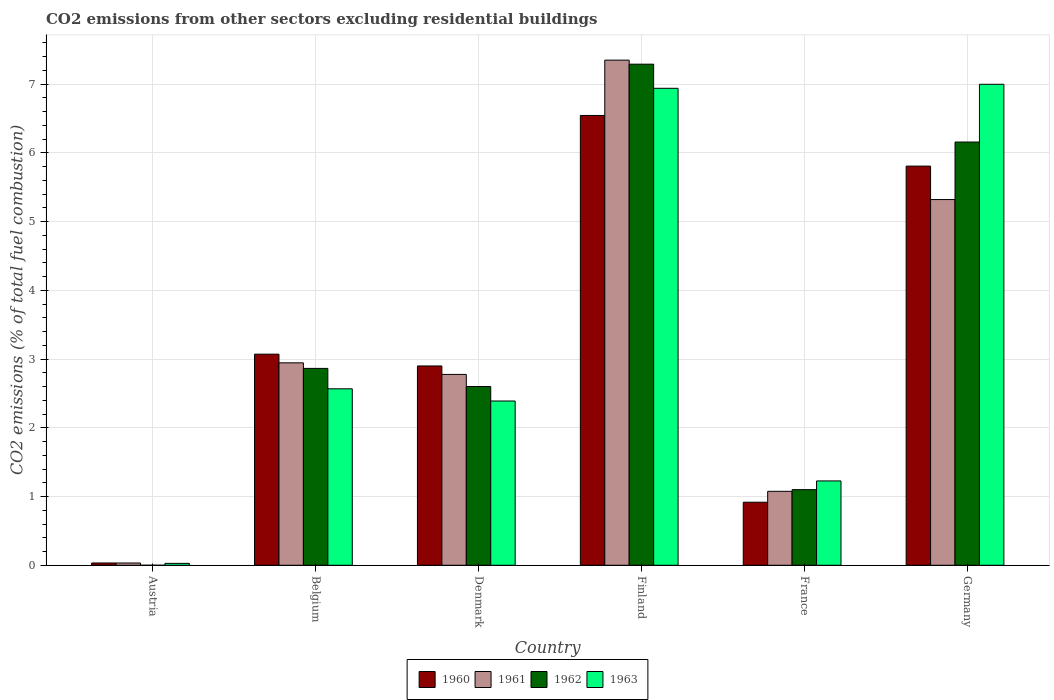How many different coloured bars are there?
Provide a succinct answer. 4. How many groups of bars are there?
Give a very brief answer. 6. Are the number of bars per tick equal to the number of legend labels?
Keep it short and to the point. No. In how many cases, is the number of bars for a given country not equal to the number of legend labels?
Your answer should be compact. 1. What is the total CO2 emitted in 1962 in France?
Make the answer very short. 1.1. Across all countries, what is the maximum total CO2 emitted in 1963?
Offer a very short reply. 7. Across all countries, what is the minimum total CO2 emitted in 1960?
Offer a terse response. 0.03. What is the total total CO2 emitted in 1962 in the graph?
Provide a succinct answer. 20.01. What is the difference between the total CO2 emitted in 1961 in Austria and that in Denmark?
Provide a short and direct response. -2.74. What is the difference between the total CO2 emitted in 1963 in Belgium and the total CO2 emitted in 1960 in Finland?
Your answer should be very brief. -3.98. What is the average total CO2 emitted in 1961 per country?
Your answer should be compact. 3.25. What is the difference between the total CO2 emitted of/in 1962 and total CO2 emitted of/in 1961 in Finland?
Make the answer very short. -0.06. In how many countries, is the total CO2 emitted in 1961 greater than 3.6?
Keep it short and to the point. 2. What is the ratio of the total CO2 emitted in 1961 in Denmark to that in France?
Your answer should be very brief. 2.58. Is the total CO2 emitted in 1961 in Denmark less than that in Germany?
Provide a succinct answer. Yes. Is the difference between the total CO2 emitted in 1962 in Denmark and Germany greater than the difference between the total CO2 emitted in 1961 in Denmark and Germany?
Make the answer very short. No. What is the difference between the highest and the second highest total CO2 emitted in 1960?
Offer a very short reply. -2.74. What is the difference between the highest and the lowest total CO2 emitted in 1962?
Provide a succinct answer. 7.29. In how many countries, is the total CO2 emitted in 1962 greater than the average total CO2 emitted in 1962 taken over all countries?
Ensure brevity in your answer.  2. Is the sum of the total CO2 emitted in 1961 in Belgium and Germany greater than the maximum total CO2 emitted in 1963 across all countries?
Offer a terse response. Yes. Is it the case that in every country, the sum of the total CO2 emitted in 1963 and total CO2 emitted in 1961 is greater than the total CO2 emitted in 1962?
Ensure brevity in your answer.  Yes. Does the graph contain grids?
Your response must be concise. Yes. How are the legend labels stacked?
Your response must be concise. Horizontal. What is the title of the graph?
Provide a short and direct response. CO2 emissions from other sectors excluding residential buildings. Does "2000" appear as one of the legend labels in the graph?
Provide a short and direct response. No. What is the label or title of the Y-axis?
Offer a very short reply. CO2 emissions (% of total fuel combustion). What is the CO2 emissions (% of total fuel combustion) in 1960 in Austria?
Keep it short and to the point. 0.03. What is the CO2 emissions (% of total fuel combustion) of 1961 in Austria?
Offer a terse response. 0.03. What is the CO2 emissions (% of total fuel combustion) in 1962 in Austria?
Your response must be concise. 0. What is the CO2 emissions (% of total fuel combustion) of 1963 in Austria?
Your answer should be very brief. 0.03. What is the CO2 emissions (% of total fuel combustion) of 1960 in Belgium?
Your answer should be compact. 3.07. What is the CO2 emissions (% of total fuel combustion) of 1961 in Belgium?
Make the answer very short. 2.95. What is the CO2 emissions (% of total fuel combustion) of 1962 in Belgium?
Keep it short and to the point. 2.86. What is the CO2 emissions (% of total fuel combustion) of 1963 in Belgium?
Your answer should be compact. 2.57. What is the CO2 emissions (% of total fuel combustion) of 1960 in Denmark?
Make the answer very short. 2.9. What is the CO2 emissions (% of total fuel combustion) of 1961 in Denmark?
Keep it short and to the point. 2.78. What is the CO2 emissions (% of total fuel combustion) in 1962 in Denmark?
Give a very brief answer. 2.6. What is the CO2 emissions (% of total fuel combustion) of 1963 in Denmark?
Provide a short and direct response. 2.39. What is the CO2 emissions (% of total fuel combustion) of 1960 in Finland?
Keep it short and to the point. 6.54. What is the CO2 emissions (% of total fuel combustion) in 1961 in Finland?
Offer a very short reply. 7.35. What is the CO2 emissions (% of total fuel combustion) of 1962 in Finland?
Give a very brief answer. 7.29. What is the CO2 emissions (% of total fuel combustion) of 1963 in Finland?
Offer a terse response. 6.94. What is the CO2 emissions (% of total fuel combustion) of 1960 in France?
Offer a very short reply. 0.92. What is the CO2 emissions (% of total fuel combustion) of 1961 in France?
Your response must be concise. 1.08. What is the CO2 emissions (% of total fuel combustion) in 1962 in France?
Your answer should be very brief. 1.1. What is the CO2 emissions (% of total fuel combustion) of 1963 in France?
Your answer should be compact. 1.23. What is the CO2 emissions (% of total fuel combustion) of 1960 in Germany?
Give a very brief answer. 5.81. What is the CO2 emissions (% of total fuel combustion) in 1961 in Germany?
Offer a terse response. 5.32. What is the CO2 emissions (% of total fuel combustion) of 1962 in Germany?
Your answer should be compact. 6.16. What is the CO2 emissions (% of total fuel combustion) in 1963 in Germany?
Your answer should be very brief. 7. Across all countries, what is the maximum CO2 emissions (% of total fuel combustion) in 1960?
Your answer should be very brief. 6.54. Across all countries, what is the maximum CO2 emissions (% of total fuel combustion) of 1961?
Provide a short and direct response. 7.35. Across all countries, what is the maximum CO2 emissions (% of total fuel combustion) in 1962?
Keep it short and to the point. 7.29. Across all countries, what is the maximum CO2 emissions (% of total fuel combustion) in 1963?
Provide a short and direct response. 7. Across all countries, what is the minimum CO2 emissions (% of total fuel combustion) of 1960?
Offer a terse response. 0.03. Across all countries, what is the minimum CO2 emissions (% of total fuel combustion) in 1961?
Ensure brevity in your answer.  0.03. Across all countries, what is the minimum CO2 emissions (% of total fuel combustion) in 1963?
Provide a short and direct response. 0.03. What is the total CO2 emissions (% of total fuel combustion) in 1960 in the graph?
Offer a terse response. 19.27. What is the total CO2 emissions (% of total fuel combustion) in 1961 in the graph?
Ensure brevity in your answer.  19.5. What is the total CO2 emissions (% of total fuel combustion) of 1962 in the graph?
Give a very brief answer. 20.01. What is the total CO2 emissions (% of total fuel combustion) of 1963 in the graph?
Offer a terse response. 20.15. What is the difference between the CO2 emissions (% of total fuel combustion) in 1960 in Austria and that in Belgium?
Your answer should be very brief. -3.04. What is the difference between the CO2 emissions (% of total fuel combustion) in 1961 in Austria and that in Belgium?
Your answer should be very brief. -2.91. What is the difference between the CO2 emissions (% of total fuel combustion) of 1963 in Austria and that in Belgium?
Provide a short and direct response. -2.54. What is the difference between the CO2 emissions (% of total fuel combustion) in 1960 in Austria and that in Denmark?
Provide a short and direct response. -2.87. What is the difference between the CO2 emissions (% of total fuel combustion) of 1961 in Austria and that in Denmark?
Provide a succinct answer. -2.74. What is the difference between the CO2 emissions (% of total fuel combustion) in 1963 in Austria and that in Denmark?
Your answer should be very brief. -2.36. What is the difference between the CO2 emissions (% of total fuel combustion) in 1960 in Austria and that in Finland?
Your response must be concise. -6.51. What is the difference between the CO2 emissions (% of total fuel combustion) of 1961 in Austria and that in Finland?
Your answer should be very brief. -7.32. What is the difference between the CO2 emissions (% of total fuel combustion) of 1963 in Austria and that in Finland?
Ensure brevity in your answer.  -6.91. What is the difference between the CO2 emissions (% of total fuel combustion) in 1960 in Austria and that in France?
Your response must be concise. -0.88. What is the difference between the CO2 emissions (% of total fuel combustion) of 1961 in Austria and that in France?
Offer a very short reply. -1.04. What is the difference between the CO2 emissions (% of total fuel combustion) in 1963 in Austria and that in France?
Give a very brief answer. -1.2. What is the difference between the CO2 emissions (% of total fuel combustion) of 1960 in Austria and that in Germany?
Make the answer very short. -5.77. What is the difference between the CO2 emissions (% of total fuel combustion) in 1961 in Austria and that in Germany?
Your answer should be very brief. -5.29. What is the difference between the CO2 emissions (% of total fuel combustion) of 1963 in Austria and that in Germany?
Keep it short and to the point. -6.97. What is the difference between the CO2 emissions (% of total fuel combustion) in 1960 in Belgium and that in Denmark?
Provide a short and direct response. 0.17. What is the difference between the CO2 emissions (% of total fuel combustion) of 1961 in Belgium and that in Denmark?
Your answer should be very brief. 0.17. What is the difference between the CO2 emissions (% of total fuel combustion) in 1962 in Belgium and that in Denmark?
Keep it short and to the point. 0.26. What is the difference between the CO2 emissions (% of total fuel combustion) of 1963 in Belgium and that in Denmark?
Your answer should be compact. 0.18. What is the difference between the CO2 emissions (% of total fuel combustion) in 1960 in Belgium and that in Finland?
Give a very brief answer. -3.47. What is the difference between the CO2 emissions (% of total fuel combustion) in 1961 in Belgium and that in Finland?
Make the answer very short. -4.4. What is the difference between the CO2 emissions (% of total fuel combustion) of 1962 in Belgium and that in Finland?
Provide a short and direct response. -4.43. What is the difference between the CO2 emissions (% of total fuel combustion) in 1963 in Belgium and that in Finland?
Offer a terse response. -4.37. What is the difference between the CO2 emissions (% of total fuel combustion) of 1960 in Belgium and that in France?
Offer a very short reply. 2.15. What is the difference between the CO2 emissions (% of total fuel combustion) in 1961 in Belgium and that in France?
Keep it short and to the point. 1.87. What is the difference between the CO2 emissions (% of total fuel combustion) in 1962 in Belgium and that in France?
Offer a very short reply. 1.76. What is the difference between the CO2 emissions (% of total fuel combustion) of 1963 in Belgium and that in France?
Make the answer very short. 1.34. What is the difference between the CO2 emissions (% of total fuel combustion) of 1960 in Belgium and that in Germany?
Provide a succinct answer. -2.74. What is the difference between the CO2 emissions (% of total fuel combustion) in 1961 in Belgium and that in Germany?
Offer a terse response. -2.38. What is the difference between the CO2 emissions (% of total fuel combustion) of 1962 in Belgium and that in Germany?
Your response must be concise. -3.29. What is the difference between the CO2 emissions (% of total fuel combustion) in 1963 in Belgium and that in Germany?
Give a very brief answer. -4.43. What is the difference between the CO2 emissions (% of total fuel combustion) of 1960 in Denmark and that in Finland?
Your response must be concise. -3.64. What is the difference between the CO2 emissions (% of total fuel combustion) in 1961 in Denmark and that in Finland?
Your answer should be very brief. -4.57. What is the difference between the CO2 emissions (% of total fuel combustion) in 1962 in Denmark and that in Finland?
Your response must be concise. -4.69. What is the difference between the CO2 emissions (% of total fuel combustion) in 1963 in Denmark and that in Finland?
Your response must be concise. -4.55. What is the difference between the CO2 emissions (% of total fuel combustion) in 1960 in Denmark and that in France?
Keep it short and to the point. 1.98. What is the difference between the CO2 emissions (% of total fuel combustion) in 1961 in Denmark and that in France?
Offer a very short reply. 1.7. What is the difference between the CO2 emissions (% of total fuel combustion) of 1962 in Denmark and that in France?
Your answer should be compact. 1.5. What is the difference between the CO2 emissions (% of total fuel combustion) of 1963 in Denmark and that in France?
Your answer should be very brief. 1.16. What is the difference between the CO2 emissions (% of total fuel combustion) of 1960 in Denmark and that in Germany?
Offer a terse response. -2.91. What is the difference between the CO2 emissions (% of total fuel combustion) in 1961 in Denmark and that in Germany?
Ensure brevity in your answer.  -2.54. What is the difference between the CO2 emissions (% of total fuel combustion) in 1962 in Denmark and that in Germany?
Make the answer very short. -3.56. What is the difference between the CO2 emissions (% of total fuel combustion) in 1963 in Denmark and that in Germany?
Give a very brief answer. -4.61. What is the difference between the CO2 emissions (% of total fuel combustion) of 1960 in Finland and that in France?
Provide a succinct answer. 5.63. What is the difference between the CO2 emissions (% of total fuel combustion) of 1961 in Finland and that in France?
Keep it short and to the point. 6.27. What is the difference between the CO2 emissions (% of total fuel combustion) in 1962 in Finland and that in France?
Make the answer very short. 6.19. What is the difference between the CO2 emissions (% of total fuel combustion) of 1963 in Finland and that in France?
Your answer should be very brief. 5.71. What is the difference between the CO2 emissions (% of total fuel combustion) in 1960 in Finland and that in Germany?
Give a very brief answer. 0.74. What is the difference between the CO2 emissions (% of total fuel combustion) in 1961 in Finland and that in Germany?
Provide a short and direct response. 2.03. What is the difference between the CO2 emissions (% of total fuel combustion) in 1962 in Finland and that in Germany?
Your response must be concise. 1.13. What is the difference between the CO2 emissions (% of total fuel combustion) in 1963 in Finland and that in Germany?
Make the answer very short. -0.06. What is the difference between the CO2 emissions (% of total fuel combustion) in 1960 in France and that in Germany?
Your answer should be compact. -4.89. What is the difference between the CO2 emissions (% of total fuel combustion) in 1961 in France and that in Germany?
Provide a short and direct response. -4.25. What is the difference between the CO2 emissions (% of total fuel combustion) in 1962 in France and that in Germany?
Make the answer very short. -5.06. What is the difference between the CO2 emissions (% of total fuel combustion) of 1963 in France and that in Germany?
Your response must be concise. -5.77. What is the difference between the CO2 emissions (% of total fuel combustion) of 1960 in Austria and the CO2 emissions (% of total fuel combustion) of 1961 in Belgium?
Make the answer very short. -2.91. What is the difference between the CO2 emissions (% of total fuel combustion) in 1960 in Austria and the CO2 emissions (% of total fuel combustion) in 1962 in Belgium?
Keep it short and to the point. -2.83. What is the difference between the CO2 emissions (% of total fuel combustion) of 1960 in Austria and the CO2 emissions (% of total fuel combustion) of 1963 in Belgium?
Provide a succinct answer. -2.53. What is the difference between the CO2 emissions (% of total fuel combustion) in 1961 in Austria and the CO2 emissions (% of total fuel combustion) in 1962 in Belgium?
Offer a very short reply. -2.83. What is the difference between the CO2 emissions (% of total fuel combustion) in 1961 in Austria and the CO2 emissions (% of total fuel combustion) in 1963 in Belgium?
Provide a short and direct response. -2.53. What is the difference between the CO2 emissions (% of total fuel combustion) of 1960 in Austria and the CO2 emissions (% of total fuel combustion) of 1961 in Denmark?
Offer a terse response. -2.74. What is the difference between the CO2 emissions (% of total fuel combustion) of 1960 in Austria and the CO2 emissions (% of total fuel combustion) of 1962 in Denmark?
Make the answer very short. -2.57. What is the difference between the CO2 emissions (% of total fuel combustion) of 1960 in Austria and the CO2 emissions (% of total fuel combustion) of 1963 in Denmark?
Provide a short and direct response. -2.36. What is the difference between the CO2 emissions (% of total fuel combustion) in 1961 in Austria and the CO2 emissions (% of total fuel combustion) in 1962 in Denmark?
Ensure brevity in your answer.  -2.57. What is the difference between the CO2 emissions (% of total fuel combustion) of 1961 in Austria and the CO2 emissions (% of total fuel combustion) of 1963 in Denmark?
Keep it short and to the point. -2.36. What is the difference between the CO2 emissions (% of total fuel combustion) of 1960 in Austria and the CO2 emissions (% of total fuel combustion) of 1961 in Finland?
Keep it short and to the point. -7.32. What is the difference between the CO2 emissions (% of total fuel combustion) in 1960 in Austria and the CO2 emissions (% of total fuel combustion) in 1962 in Finland?
Provide a succinct answer. -7.26. What is the difference between the CO2 emissions (% of total fuel combustion) in 1960 in Austria and the CO2 emissions (% of total fuel combustion) in 1963 in Finland?
Offer a very short reply. -6.91. What is the difference between the CO2 emissions (% of total fuel combustion) of 1961 in Austria and the CO2 emissions (% of total fuel combustion) of 1962 in Finland?
Provide a succinct answer. -7.26. What is the difference between the CO2 emissions (% of total fuel combustion) of 1961 in Austria and the CO2 emissions (% of total fuel combustion) of 1963 in Finland?
Keep it short and to the point. -6.91. What is the difference between the CO2 emissions (% of total fuel combustion) in 1960 in Austria and the CO2 emissions (% of total fuel combustion) in 1961 in France?
Your answer should be compact. -1.04. What is the difference between the CO2 emissions (% of total fuel combustion) of 1960 in Austria and the CO2 emissions (% of total fuel combustion) of 1962 in France?
Offer a very short reply. -1.07. What is the difference between the CO2 emissions (% of total fuel combustion) in 1960 in Austria and the CO2 emissions (% of total fuel combustion) in 1963 in France?
Keep it short and to the point. -1.19. What is the difference between the CO2 emissions (% of total fuel combustion) in 1961 in Austria and the CO2 emissions (% of total fuel combustion) in 1962 in France?
Offer a very short reply. -1.07. What is the difference between the CO2 emissions (% of total fuel combustion) of 1961 in Austria and the CO2 emissions (% of total fuel combustion) of 1963 in France?
Your answer should be compact. -1.19. What is the difference between the CO2 emissions (% of total fuel combustion) in 1960 in Austria and the CO2 emissions (% of total fuel combustion) in 1961 in Germany?
Make the answer very short. -5.29. What is the difference between the CO2 emissions (% of total fuel combustion) in 1960 in Austria and the CO2 emissions (% of total fuel combustion) in 1962 in Germany?
Provide a short and direct response. -6.12. What is the difference between the CO2 emissions (% of total fuel combustion) of 1960 in Austria and the CO2 emissions (% of total fuel combustion) of 1963 in Germany?
Give a very brief answer. -6.97. What is the difference between the CO2 emissions (% of total fuel combustion) in 1961 in Austria and the CO2 emissions (% of total fuel combustion) in 1962 in Germany?
Your answer should be compact. -6.12. What is the difference between the CO2 emissions (% of total fuel combustion) of 1961 in Austria and the CO2 emissions (% of total fuel combustion) of 1963 in Germany?
Your response must be concise. -6.97. What is the difference between the CO2 emissions (% of total fuel combustion) in 1960 in Belgium and the CO2 emissions (% of total fuel combustion) in 1961 in Denmark?
Your response must be concise. 0.29. What is the difference between the CO2 emissions (% of total fuel combustion) in 1960 in Belgium and the CO2 emissions (% of total fuel combustion) in 1962 in Denmark?
Your answer should be very brief. 0.47. What is the difference between the CO2 emissions (% of total fuel combustion) of 1960 in Belgium and the CO2 emissions (% of total fuel combustion) of 1963 in Denmark?
Keep it short and to the point. 0.68. What is the difference between the CO2 emissions (% of total fuel combustion) of 1961 in Belgium and the CO2 emissions (% of total fuel combustion) of 1962 in Denmark?
Your answer should be compact. 0.34. What is the difference between the CO2 emissions (% of total fuel combustion) in 1961 in Belgium and the CO2 emissions (% of total fuel combustion) in 1963 in Denmark?
Offer a terse response. 0.56. What is the difference between the CO2 emissions (% of total fuel combustion) in 1962 in Belgium and the CO2 emissions (% of total fuel combustion) in 1963 in Denmark?
Give a very brief answer. 0.47. What is the difference between the CO2 emissions (% of total fuel combustion) in 1960 in Belgium and the CO2 emissions (% of total fuel combustion) in 1961 in Finland?
Offer a terse response. -4.28. What is the difference between the CO2 emissions (% of total fuel combustion) in 1960 in Belgium and the CO2 emissions (% of total fuel combustion) in 1962 in Finland?
Ensure brevity in your answer.  -4.22. What is the difference between the CO2 emissions (% of total fuel combustion) in 1960 in Belgium and the CO2 emissions (% of total fuel combustion) in 1963 in Finland?
Ensure brevity in your answer.  -3.87. What is the difference between the CO2 emissions (% of total fuel combustion) of 1961 in Belgium and the CO2 emissions (% of total fuel combustion) of 1962 in Finland?
Make the answer very short. -4.35. What is the difference between the CO2 emissions (% of total fuel combustion) in 1961 in Belgium and the CO2 emissions (% of total fuel combustion) in 1963 in Finland?
Your response must be concise. -3.99. What is the difference between the CO2 emissions (% of total fuel combustion) of 1962 in Belgium and the CO2 emissions (% of total fuel combustion) of 1963 in Finland?
Your answer should be very brief. -4.08. What is the difference between the CO2 emissions (% of total fuel combustion) of 1960 in Belgium and the CO2 emissions (% of total fuel combustion) of 1961 in France?
Keep it short and to the point. 2. What is the difference between the CO2 emissions (% of total fuel combustion) in 1960 in Belgium and the CO2 emissions (% of total fuel combustion) in 1962 in France?
Ensure brevity in your answer.  1.97. What is the difference between the CO2 emissions (% of total fuel combustion) of 1960 in Belgium and the CO2 emissions (% of total fuel combustion) of 1963 in France?
Your answer should be compact. 1.84. What is the difference between the CO2 emissions (% of total fuel combustion) of 1961 in Belgium and the CO2 emissions (% of total fuel combustion) of 1962 in France?
Make the answer very short. 1.84. What is the difference between the CO2 emissions (% of total fuel combustion) of 1961 in Belgium and the CO2 emissions (% of total fuel combustion) of 1963 in France?
Ensure brevity in your answer.  1.72. What is the difference between the CO2 emissions (% of total fuel combustion) in 1962 in Belgium and the CO2 emissions (% of total fuel combustion) in 1963 in France?
Your answer should be very brief. 1.64. What is the difference between the CO2 emissions (% of total fuel combustion) of 1960 in Belgium and the CO2 emissions (% of total fuel combustion) of 1961 in Germany?
Your answer should be compact. -2.25. What is the difference between the CO2 emissions (% of total fuel combustion) of 1960 in Belgium and the CO2 emissions (% of total fuel combustion) of 1962 in Germany?
Ensure brevity in your answer.  -3.09. What is the difference between the CO2 emissions (% of total fuel combustion) of 1960 in Belgium and the CO2 emissions (% of total fuel combustion) of 1963 in Germany?
Keep it short and to the point. -3.93. What is the difference between the CO2 emissions (% of total fuel combustion) of 1961 in Belgium and the CO2 emissions (% of total fuel combustion) of 1962 in Germany?
Offer a terse response. -3.21. What is the difference between the CO2 emissions (% of total fuel combustion) in 1961 in Belgium and the CO2 emissions (% of total fuel combustion) in 1963 in Germany?
Make the answer very short. -4.05. What is the difference between the CO2 emissions (% of total fuel combustion) of 1962 in Belgium and the CO2 emissions (% of total fuel combustion) of 1963 in Germany?
Make the answer very short. -4.13. What is the difference between the CO2 emissions (% of total fuel combustion) in 1960 in Denmark and the CO2 emissions (% of total fuel combustion) in 1961 in Finland?
Offer a terse response. -4.45. What is the difference between the CO2 emissions (% of total fuel combustion) of 1960 in Denmark and the CO2 emissions (% of total fuel combustion) of 1962 in Finland?
Provide a succinct answer. -4.39. What is the difference between the CO2 emissions (% of total fuel combustion) of 1960 in Denmark and the CO2 emissions (% of total fuel combustion) of 1963 in Finland?
Provide a succinct answer. -4.04. What is the difference between the CO2 emissions (% of total fuel combustion) of 1961 in Denmark and the CO2 emissions (% of total fuel combustion) of 1962 in Finland?
Your answer should be very brief. -4.51. What is the difference between the CO2 emissions (% of total fuel combustion) of 1961 in Denmark and the CO2 emissions (% of total fuel combustion) of 1963 in Finland?
Keep it short and to the point. -4.16. What is the difference between the CO2 emissions (% of total fuel combustion) of 1962 in Denmark and the CO2 emissions (% of total fuel combustion) of 1963 in Finland?
Give a very brief answer. -4.34. What is the difference between the CO2 emissions (% of total fuel combustion) of 1960 in Denmark and the CO2 emissions (% of total fuel combustion) of 1961 in France?
Ensure brevity in your answer.  1.82. What is the difference between the CO2 emissions (% of total fuel combustion) of 1960 in Denmark and the CO2 emissions (% of total fuel combustion) of 1962 in France?
Keep it short and to the point. 1.8. What is the difference between the CO2 emissions (% of total fuel combustion) in 1960 in Denmark and the CO2 emissions (% of total fuel combustion) in 1963 in France?
Provide a succinct answer. 1.67. What is the difference between the CO2 emissions (% of total fuel combustion) of 1961 in Denmark and the CO2 emissions (% of total fuel combustion) of 1962 in France?
Give a very brief answer. 1.68. What is the difference between the CO2 emissions (% of total fuel combustion) in 1961 in Denmark and the CO2 emissions (% of total fuel combustion) in 1963 in France?
Keep it short and to the point. 1.55. What is the difference between the CO2 emissions (% of total fuel combustion) in 1962 in Denmark and the CO2 emissions (% of total fuel combustion) in 1963 in France?
Your answer should be very brief. 1.37. What is the difference between the CO2 emissions (% of total fuel combustion) of 1960 in Denmark and the CO2 emissions (% of total fuel combustion) of 1961 in Germany?
Ensure brevity in your answer.  -2.42. What is the difference between the CO2 emissions (% of total fuel combustion) in 1960 in Denmark and the CO2 emissions (% of total fuel combustion) in 1962 in Germany?
Offer a terse response. -3.26. What is the difference between the CO2 emissions (% of total fuel combustion) of 1960 in Denmark and the CO2 emissions (% of total fuel combustion) of 1963 in Germany?
Your answer should be compact. -4.1. What is the difference between the CO2 emissions (% of total fuel combustion) in 1961 in Denmark and the CO2 emissions (% of total fuel combustion) in 1962 in Germany?
Offer a very short reply. -3.38. What is the difference between the CO2 emissions (% of total fuel combustion) of 1961 in Denmark and the CO2 emissions (% of total fuel combustion) of 1963 in Germany?
Your answer should be very brief. -4.22. What is the difference between the CO2 emissions (% of total fuel combustion) in 1962 in Denmark and the CO2 emissions (% of total fuel combustion) in 1963 in Germany?
Give a very brief answer. -4.4. What is the difference between the CO2 emissions (% of total fuel combustion) of 1960 in Finland and the CO2 emissions (% of total fuel combustion) of 1961 in France?
Your answer should be very brief. 5.47. What is the difference between the CO2 emissions (% of total fuel combustion) of 1960 in Finland and the CO2 emissions (% of total fuel combustion) of 1962 in France?
Your answer should be very brief. 5.44. What is the difference between the CO2 emissions (% of total fuel combustion) of 1960 in Finland and the CO2 emissions (% of total fuel combustion) of 1963 in France?
Give a very brief answer. 5.32. What is the difference between the CO2 emissions (% of total fuel combustion) in 1961 in Finland and the CO2 emissions (% of total fuel combustion) in 1962 in France?
Your answer should be very brief. 6.25. What is the difference between the CO2 emissions (% of total fuel combustion) in 1961 in Finland and the CO2 emissions (% of total fuel combustion) in 1963 in France?
Ensure brevity in your answer.  6.12. What is the difference between the CO2 emissions (% of total fuel combustion) of 1962 in Finland and the CO2 emissions (% of total fuel combustion) of 1963 in France?
Provide a succinct answer. 6.06. What is the difference between the CO2 emissions (% of total fuel combustion) in 1960 in Finland and the CO2 emissions (% of total fuel combustion) in 1961 in Germany?
Give a very brief answer. 1.22. What is the difference between the CO2 emissions (% of total fuel combustion) in 1960 in Finland and the CO2 emissions (% of total fuel combustion) in 1962 in Germany?
Ensure brevity in your answer.  0.39. What is the difference between the CO2 emissions (% of total fuel combustion) in 1960 in Finland and the CO2 emissions (% of total fuel combustion) in 1963 in Germany?
Give a very brief answer. -0.45. What is the difference between the CO2 emissions (% of total fuel combustion) of 1961 in Finland and the CO2 emissions (% of total fuel combustion) of 1962 in Germany?
Your answer should be very brief. 1.19. What is the difference between the CO2 emissions (% of total fuel combustion) of 1961 in Finland and the CO2 emissions (% of total fuel combustion) of 1963 in Germany?
Offer a terse response. 0.35. What is the difference between the CO2 emissions (% of total fuel combustion) in 1962 in Finland and the CO2 emissions (% of total fuel combustion) in 1963 in Germany?
Your answer should be very brief. 0.29. What is the difference between the CO2 emissions (% of total fuel combustion) in 1960 in France and the CO2 emissions (% of total fuel combustion) in 1961 in Germany?
Make the answer very short. -4.4. What is the difference between the CO2 emissions (% of total fuel combustion) of 1960 in France and the CO2 emissions (% of total fuel combustion) of 1962 in Germany?
Provide a short and direct response. -5.24. What is the difference between the CO2 emissions (% of total fuel combustion) of 1960 in France and the CO2 emissions (% of total fuel combustion) of 1963 in Germany?
Offer a terse response. -6.08. What is the difference between the CO2 emissions (% of total fuel combustion) of 1961 in France and the CO2 emissions (% of total fuel combustion) of 1962 in Germany?
Offer a very short reply. -5.08. What is the difference between the CO2 emissions (% of total fuel combustion) in 1961 in France and the CO2 emissions (% of total fuel combustion) in 1963 in Germany?
Provide a short and direct response. -5.92. What is the difference between the CO2 emissions (% of total fuel combustion) in 1962 in France and the CO2 emissions (% of total fuel combustion) in 1963 in Germany?
Your answer should be very brief. -5.9. What is the average CO2 emissions (% of total fuel combustion) in 1960 per country?
Keep it short and to the point. 3.21. What is the average CO2 emissions (% of total fuel combustion) of 1961 per country?
Give a very brief answer. 3.25. What is the average CO2 emissions (% of total fuel combustion) of 1962 per country?
Provide a succinct answer. 3.34. What is the average CO2 emissions (% of total fuel combustion) in 1963 per country?
Offer a very short reply. 3.36. What is the difference between the CO2 emissions (% of total fuel combustion) in 1960 and CO2 emissions (% of total fuel combustion) in 1963 in Austria?
Provide a short and direct response. 0.01. What is the difference between the CO2 emissions (% of total fuel combustion) in 1961 and CO2 emissions (% of total fuel combustion) in 1963 in Austria?
Make the answer very short. 0.01. What is the difference between the CO2 emissions (% of total fuel combustion) of 1960 and CO2 emissions (% of total fuel combustion) of 1961 in Belgium?
Offer a very short reply. 0.13. What is the difference between the CO2 emissions (% of total fuel combustion) in 1960 and CO2 emissions (% of total fuel combustion) in 1962 in Belgium?
Offer a very short reply. 0.21. What is the difference between the CO2 emissions (% of total fuel combustion) of 1960 and CO2 emissions (% of total fuel combustion) of 1963 in Belgium?
Keep it short and to the point. 0.5. What is the difference between the CO2 emissions (% of total fuel combustion) of 1961 and CO2 emissions (% of total fuel combustion) of 1962 in Belgium?
Offer a terse response. 0.08. What is the difference between the CO2 emissions (% of total fuel combustion) of 1961 and CO2 emissions (% of total fuel combustion) of 1963 in Belgium?
Give a very brief answer. 0.38. What is the difference between the CO2 emissions (% of total fuel combustion) in 1962 and CO2 emissions (% of total fuel combustion) in 1963 in Belgium?
Your response must be concise. 0.3. What is the difference between the CO2 emissions (% of total fuel combustion) in 1960 and CO2 emissions (% of total fuel combustion) in 1961 in Denmark?
Your response must be concise. 0.12. What is the difference between the CO2 emissions (% of total fuel combustion) of 1960 and CO2 emissions (% of total fuel combustion) of 1962 in Denmark?
Keep it short and to the point. 0.3. What is the difference between the CO2 emissions (% of total fuel combustion) in 1960 and CO2 emissions (% of total fuel combustion) in 1963 in Denmark?
Your response must be concise. 0.51. What is the difference between the CO2 emissions (% of total fuel combustion) in 1961 and CO2 emissions (% of total fuel combustion) in 1962 in Denmark?
Make the answer very short. 0.18. What is the difference between the CO2 emissions (% of total fuel combustion) in 1961 and CO2 emissions (% of total fuel combustion) in 1963 in Denmark?
Offer a very short reply. 0.39. What is the difference between the CO2 emissions (% of total fuel combustion) of 1962 and CO2 emissions (% of total fuel combustion) of 1963 in Denmark?
Give a very brief answer. 0.21. What is the difference between the CO2 emissions (% of total fuel combustion) in 1960 and CO2 emissions (% of total fuel combustion) in 1961 in Finland?
Your response must be concise. -0.81. What is the difference between the CO2 emissions (% of total fuel combustion) in 1960 and CO2 emissions (% of total fuel combustion) in 1962 in Finland?
Keep it short and to the point. -0.75. What is the difference between the CO2 emissions (% of total fuel combustion) of 1960 and CO2 emissions (% of total fuel combustion) of 1963 in Finland?
Make the answer very short. -0.4. What is the difference between the CO2 emissions (% of total fuel combustion) of 1961 and CO2 emissions (% of total fuel combustion) of 1962 in Finland?
Provide a succinct answer. 0.06. What is the difference between the CO2 emissions (% of total fuel combustion) of 1961 and CO2 emissions (% of total fuel combustion) of 1963 in Finland?
Provide a succinct answer. 0.41. What is the difference between the CO2 emissions (% of total fuel combustion) of 1962 and CO2 emissions (% of total fuel combustion) of 1963 in Finland?
Your answer should be compact. 0.35. What is the difference between the CO2 emissions (% of total fuel combustion) in 1960 and CO2 emissions (% of total fuel combustion) in 1961 in France?
Your answer should be very brief. -0.16. What is the difference between the CO2 emissions (% of total fuel combustion) of 1960 and CO2 emissions (% of total fuel combustion) of 1962 in France?
Provide a succinct answer. -0.18. What is the difference between the CO2 emissions (% of total fuel combustion) of 1960 and CO2 emissions (% of total fuel combustion) of 1963 in France?
Offer a terse response. -0.31. What is the difference between the CO2 emissions (% of total fuel combustion) in 1961 and CO2 emissions (% of total fuel combustion) in 1962 in France?
Your answer should be compact. -0.02. What is the difference between the CO2 emissions (% of total fuel combustion) of 1961 and CO2 emissions (% of total fuel combustion) of 1963 in France?
Offer a very short reply. -0.15. What is the difference between the CO2 emissions (% of total fuel combustion) in 1962 and CO2 emissions (% of total fuel combustion) in 1963 in France?
Keep it short and to the point. -0.13. What is the difference between the CO2 emissions (% of total fuel combustion) of 1960 and CO2 emissions (% of total fuel combustion) of 1961 in Germany?
Give a very brief answer. 0.49. What is the difference between the CO2 emissions (% of total fuel combustion) of 1960 and CO2 emissions (% of total fuel combustion) of 1962 in Germany?
Keep it short and to the point. -0.35. What is the difference between the CO2 emissions (% of total fuel combustion) of 1960 and CO2 emissions (% of total fuel combustion) of 1963 in Germany?
Provide a succinct answer. -1.19. What is the difference between the CO2 emissions (% of total fuel combustion) in 1961 and CO2 emissions (% of total fuel combustion) in 1962 in Germany?
Offer a very short reply. -0.84. What is the difference between the CO2 emissions (% of total fuel combustion) in 1961 and CO2 emissions (% of total fuel combustion) in 1963 in Germany?
Make the answer very short. -1.68. What is the difference between the CO2 emissions (% of total fuel combustion) of 1962 and CO2 emissions (% of total fuel combustion) of 1963 in Germany?
Ensure brevity in your answer.  -0.84. What is the ratio of the CO2 emissions (% of total fuel combustion) of 1960 in Austria to that in Belgium?
Provide a short and direct response. 0.01. What is the ratio of the CO2 emissions (% of total fuel combustion) in 1961 in Austria to that in Belgium?
Keep it short and to the point. 0.01. What is the ratio of the CO2 emissions (% of total fuel combustion) in 1963 in Austria to that in Belgium?
Offer a terse response. 0.01. What is the ratio of the CO2 emissions (% of total fuel combustion) of 1960 in Austria to that in Denmark?
Provide a short and direct response. 0.01. What is the ratio of the CO2 emissions (% of total fuel combustion) in 1961 in Austria to that in Denmark?
Provide a succinct answer. 0.01. What is the ratio of the CO2 emissions (% of total fuel combustion) in 1963 in Austria to that in Denmark?
Offer a very short reply. 0.01. What is the ratio of the CO2 emissions (% of total fuel combustion) in 1960 in Austria to that in Finland?
Give a very brief answer. 0.01. What is the ratio of the CO2 emissions (% of total fuel combustion) of 1961 in Austria to that in Finland?
Provide a short and direct response. 0. What is the ratio of the CO2 emissions (% of total fuel combustion) of 1963 in Austria to that in Finland?
Keep it short and to the point. 0. What is the ratio of the CO2 emissions (% of total fuel combustion) of 1960 in Austria to that in France?
Give a very brief answer. 0.04. What is the ratio of the CO2 emissions (% of total fuel combustion) of 1961 in Austria to that in France?
Give a very brief answer. 0.03. What is the ratio of the CO2 emissions (% of total fuel combustion) of 1963 in Austria to that in France?
Ensure brevity in your answer.  0.02. What is the ratio of the CO2 emissions (% of total fuel combustion) of 1960 in Austria to that in Germany?
Offer a very short reply. 0.01. What is the ratio of the CO2 emissions (% of total fuel combustion) in 1961 in Austria to that in Germany?
Your answer should be compact. 0.01. What is the ratio of the CO2 emissions (% of total fuel combustion) in 1963 in Austria to that in Germany?
Offer a terse response. 0. What is the ratio of the CO2 emissions (% of total fuel combustion) of 1960 in Belgium to that in Denmark?
Make the answer very short. 1.06. What is the ratio of the CO2 emissions (% of total fuel combustion) in 1961 in Belgium to that in Denmark?
Offer a very short reply. 1.06. What is the ratio of the CO2 emissions (% of total fuel combustion) of 1962 in Belgium to that in Denmark?
Keep it short and to the point. 1.1. What is the ratio of the CO2 emissions (% of total fuel combustion) in 1963 in Belgium to that in Denmark?
Provide a succinct answer. 1.07. What is the ratio of the CO2 emissions (% of total fuel combustion) of 1960 in Belgium to that in Finland?
Provide a succinct answer. 0.47. What is the ratio of the CO2 emissions (% of total fuel combustion) in 1961 in Belgium to that in Finland?
Make the answer very short. 0.4. What is the ratio of the CO2 emissions (% of total fuel combustion) in 1962 in Belgium to that in Finland?
Offer a terse response. 0.39. What is the ratio of the CO2 emissions (% of total fuel combustion) of 1963 in Belgium to that in Finland?
Provide a short and direct response. 0.37. What is the ratio of the CO2 emissions (% of total fuel combustion) of 1960 in Belgium to that in France?
Provide a succinct answer. 3.35. What is the ratio of the CO2 emissions (% of total fuel combustion) of 1961 in Belgium to that in France?
Keep it short and to the point. 2.74. What is the ratio of the CO2 emissions (% of total fuel combustion) of 1962 in Belgium to that in France?
Your answer should be very brief. 2.6. What is the ratio of the CO2 emissions (% of total fuel combustion) of 1963 in Belgium to that in France?
Keep it short and to the point. 2.09. What is the ratio of the CO2 emissions (% of total fuel combustion) of 1960 in Belgium to that in Germany?
Make the answer very short. 0.53. What is the ratio of the CO2 emissions (% of total fuel combustion) of 1961 in Belgium to that in Germany?
Provide a short and direct response. 0.55. What is the ratio of the CO2 emissions (% of total fuel combustion) of 1962 in Belgium to that in Germany?
Give a very brief answer. 0.47. What is the ratio of the CO2 emissions (% of total fuel combustion) in 1963 in Belgium to that in Germany?
Offer a terse response. 0.37. What is the ratio of the CO2 emissions (% of total fuel combustion) in 1960 in Denmark to that in Finland?
Give a very brief answer. 0.44. What is the ratio of the CO2 emissions (% of total fuel combustion) in 1961 in Denmark to that in Finland?
Provide a succinct answer. 0.38. What is the ratio of the CO2 emissions (% of total fuel combustion) of 1962 in Denmark to that in Finland?
Offer a very short reply. 0.36. What is the ratio of the CO2 emissions (% of total fuel combustion) of 1963 in Denmark to that in Finland?
Give a very brief answer. 0.34. What is the ratio of the CO2 emissions (% of total fuel combustion) in 1960 in Denmark to that in France?
Make the answer very short. 3.16. What is the ratio of the CO2 emissions (% of total fuel combustion) of 1961 in Denmark to that in France?
Keep it short and to the point. 2.58. What is the ratio of the CO2 emissions (% of total fuel combustion) in 1962 in Denmark to that in France?
Provide a succinct answer. 2.36. What is the ratio of the CO2 emissions (% of total fuel combustion) of 1963 in Denmark to that in France?
Your answer should be compact. 1.95. What is the ratio of the CO2 emissions (% of total fuel combustion) of 1960 in Denmark to that in Germany?
Keep it short and to the point. 0.5. What is the ratio of the CO2 emissions (% of total fuel combustion) of 1961 in Denmark to that in Germany?
Your response must be concise. 0.52. What is the ratio of the CO2 emissions (% of total fuel combustion) of 1962 in Denmark to that in Germany?
Provide a short and direct response. 0.42. What is the ratio of the CO2 emissions (% of total fuel combustion) in 1963 in Denmark to that in Germany?
Make the answer very short. 0.34. What is the ratio of the CO2 emissions (% of total fuel combustion) of 1960 in Finland to that in France?
Give a very brief answer. 7.14. What is the ratio of the CO2 emissions (% of total fuel combustion) in 1961 in Finland to that in France?
Give a very brief answer. 6.83. What is the ratio of the CO2 emissions (% of total fuel combustion) of 1962 in Finland to that in France?
Give a very brief answer. 6.63. What is the ratio of the CO2 emissions (% of total fuel combustion) of 1963 in Finland to that in France?
Provide a succinct answer. 5.66. What is the ratio of the CO2 emissions (% of total fuel combustion) in 1960 in Finland to that in Germany?
Give a very brief answer. 1.13. What is the ratio of the CO2 emissions (% of total fuel combustion) of 1961 in Finland to that in Germany?
Give a very brief answer. 1.38. What is the ratio of the CO2 emissions (% of total fuel combustion) in 1962 in Finland to that in Germany?
Ensure brevity in your answer.  1.18. What is the ratio of the CO2 emissions (% of total fuel combustion) of 1963 in Finland to that in Germany?
Provide a succinct answer. 0.99. What is the ratio of the CO2 emissions (% of total fuel combustion) in 1960 in France to that in Germany?
Offer a very short reply. 0.16. What is the ratio of the CO2 emissions (% of total fuel combustion) of 1961 in France to that in Germany?
Give a very brief answer. 0.2. What is the ratio of the CO2 emissions (% of total fuel combustion) of 1962 in France to that in Germany?
Provide a succinct answer. 0.18. What is the ratio of the CO2 emissions (% of total fuel combustion) of 1963 in France to that in Germany?
Provide a succinct answer. 0.18. What is the difference between the highest and the second highest CO2 emissions (% of total fuel combustion) in 1960?
Your response must be concise. 0.74. What is the difference between the highest and the second highest CO2 emissions (% of total fuel combustion) of 1961?
Ensure brevity in your answer.  2.03. What is the difference between the highest and the second highest CO2 emissions (% of total fuel combustion) in 1962?
Offer a terse response. 1.13. What is the difference between the highest and the second highest CO2 emissions (% of total fuel combustion) in 1963?
Your answer should be compact. 0.06. What is the difference between the highest and the lowest CO2 emissions (% of total fuel combustion) of 1960?
Make the answer very short. 6.51. What is the difference between the highest and the lowest CO2 emissions (% of total fuel combustion) in 1961?
Offer a very short reply. 7.32. What is the difference between the highest and the lowest CO2 emissions (% of total fuel combustion) of 1962?
Make the answer very short. 7.29. What is the difference between the highest and the lowest CO2 emissions (% of total fuel combustion) of 1963?
Ensure brevity in your answer.  6.97. 